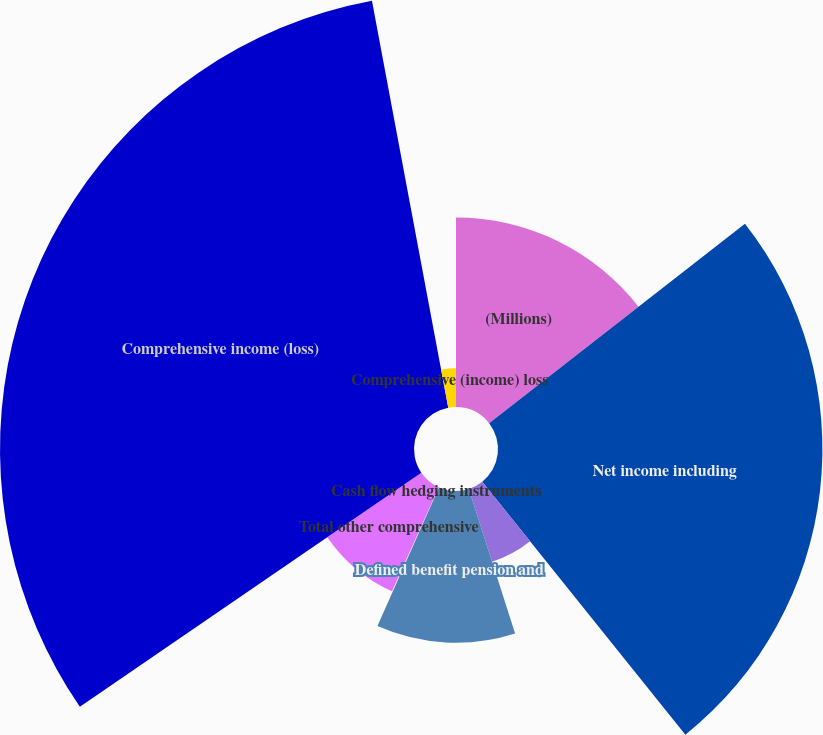Convert chart to OTSL. <chart><loc_0><loc_0><loc_500><loc_500><pie_chart><fcel>(Millions)<fcel>Net income including<fcel>Cumulative translation<fcel>Defined benefit pension and<fcel>Cash flow hedging instruments<fcel>Total other comprehensive<fcel>Comprehensive income (loss)<fcel>Comprehensive (income) loss<nl><fcel>14.46%<fcel>24.77%<fcel>5.83%<fcel>11.58%<fcel>0.08%<fcel>8.71%<fcel>31.61%<fcel>2.95%<nl></chart> 